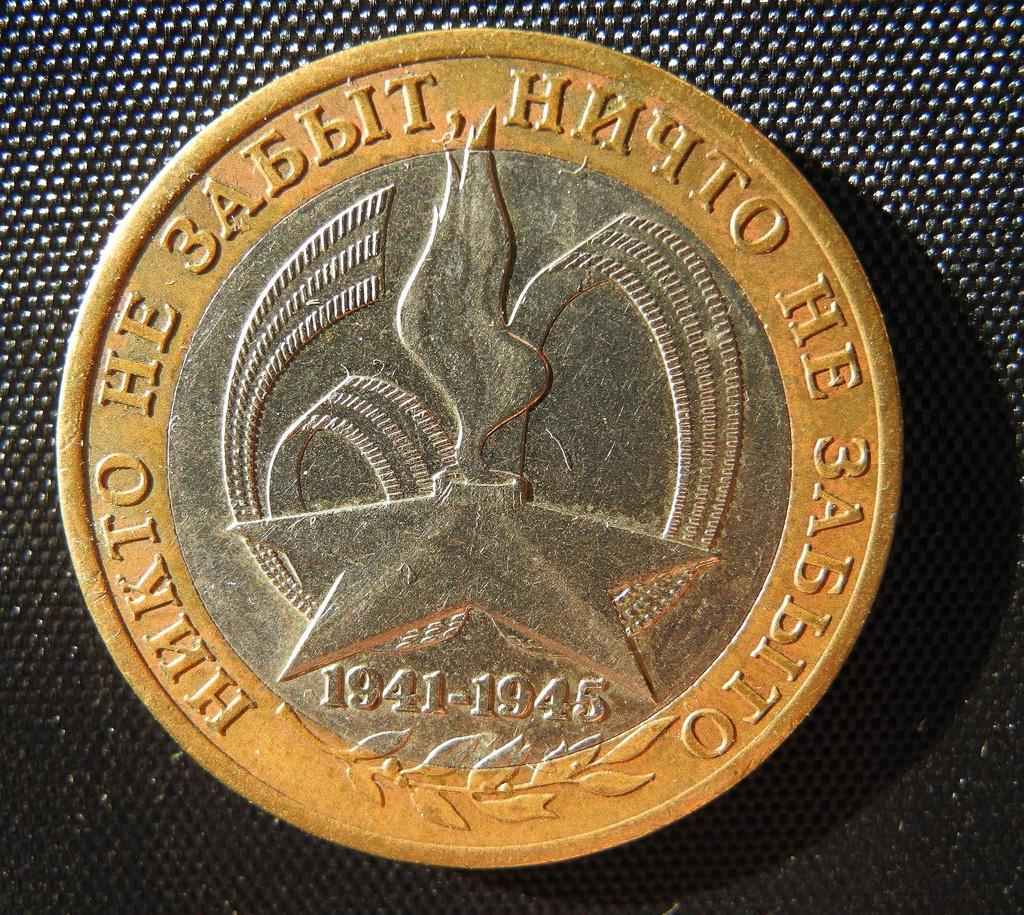Provide a one-sentence caption for the provided image. A coin from 1941-1945 with foreign inscription on it. 